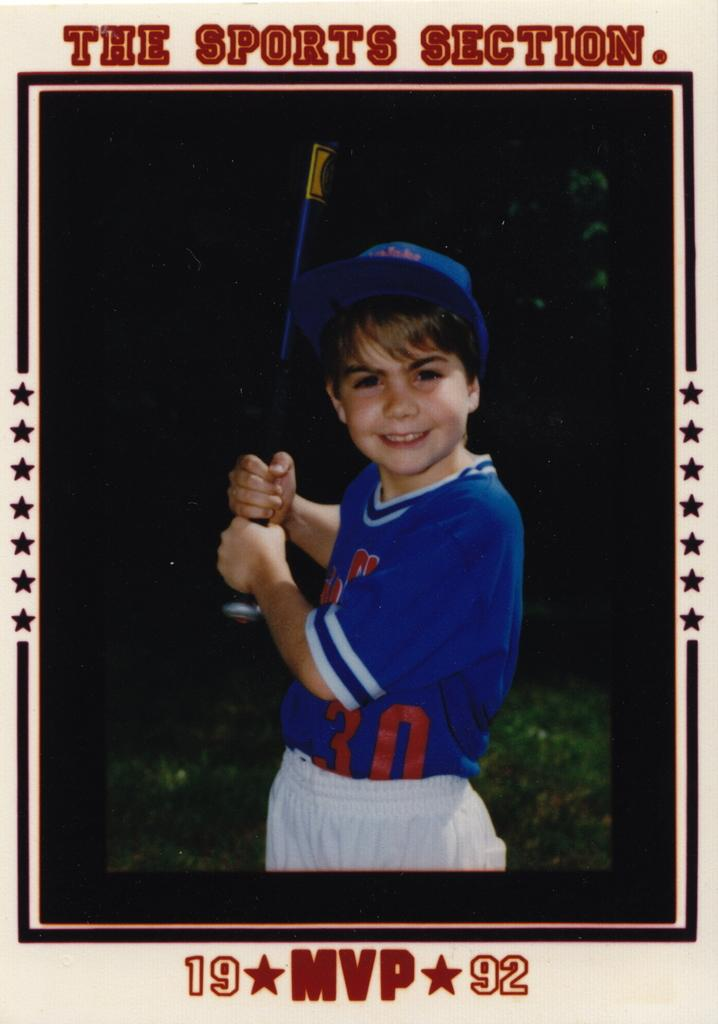<image>
Give a short and clear explanation of the subsequent image. a player card that has the sports section on it 